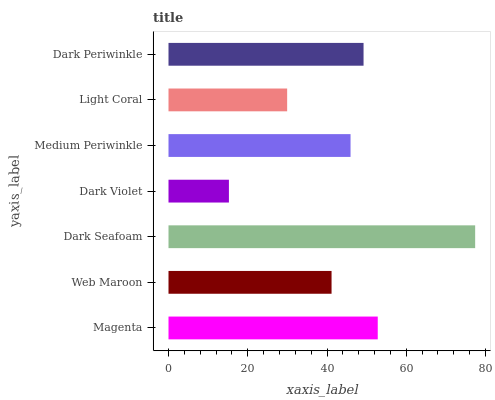Is Dark Violet the minimum?
Answer yes or no. Yes. Is Dark Seafoam the maximum?
Answer yes or no. Yes. Is Web Maroon the minimum?
Answer yes or no. No. Is Web Maroon the maximum?
Answer yes or no. No. Is Magenta greater than Web Maroon?
Answer yes or no. Yes. Is Web Maroon less than Magenta?
Answer yes or no. Yes. Is Web Maroon greater than Magenta?
Answer yes or no. No. Is Magenta less than Web Maroon?
Answer yes or no. No. Is Medium Periwinkle the high median?
Answer yes or no. Yes. Is Medium Periwinkle the low median?
Answer yes or no. Yes. Is Web Maroon the high median?
Answer yes or no. No. Is Dark Seafoam the low median?
Answer yes or no. No. 